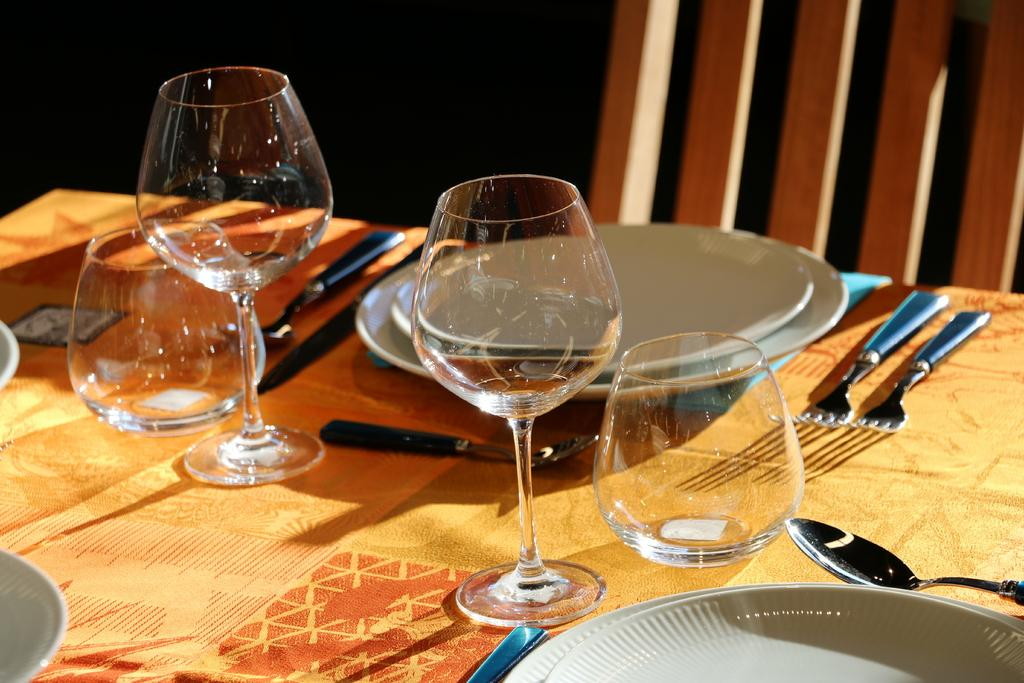What is covering the table in the image? There is an orange cloth on the table in the image. How many glasses are on the table? There are four glasses on the table. How many plates are on the table? There are two plates on the table. How many scoops are on the table? There are two scoops on the table. How many forks are on the table? There are two forks on the table. What is in front of the table? There is a chair in front of the table. What type of card game is being played on the table in the image? There is no card game present in the image; it only shows a table with various items on it. Can you see any dinosaurs in the image? There are no dinosaurs present in the image. 